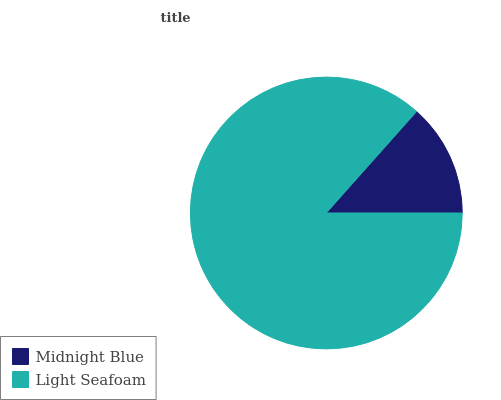Is Midnight Blue the minimum?
Answer yes or no. Yes. Is Light Seafoam the maximum?
Answer yes or no. Yes. Is Light Seafoam the minimum?
Answer yes or no. No. Is Light Seafoam greater than Midnight Blue?
Answer yes or no. Yes. Is Midnight Blue less than Light Seafoam?
Answer yes or no. Yes. Is Midnight Blue greater than Light Seafoam?
Answer yes or no. No. Is Light Seafoam less than Midnight Blue?
Answer yes or no. No. Is Light Seafoam the high median?
Answer yes or no. Yes. Is Midnight Blue the low median?
Answer yes or no. Yes. Is Midnight Blue the high median?
Answer yes or no. No. Is Light Seafoam the low median?
Answer yes or no. No. 